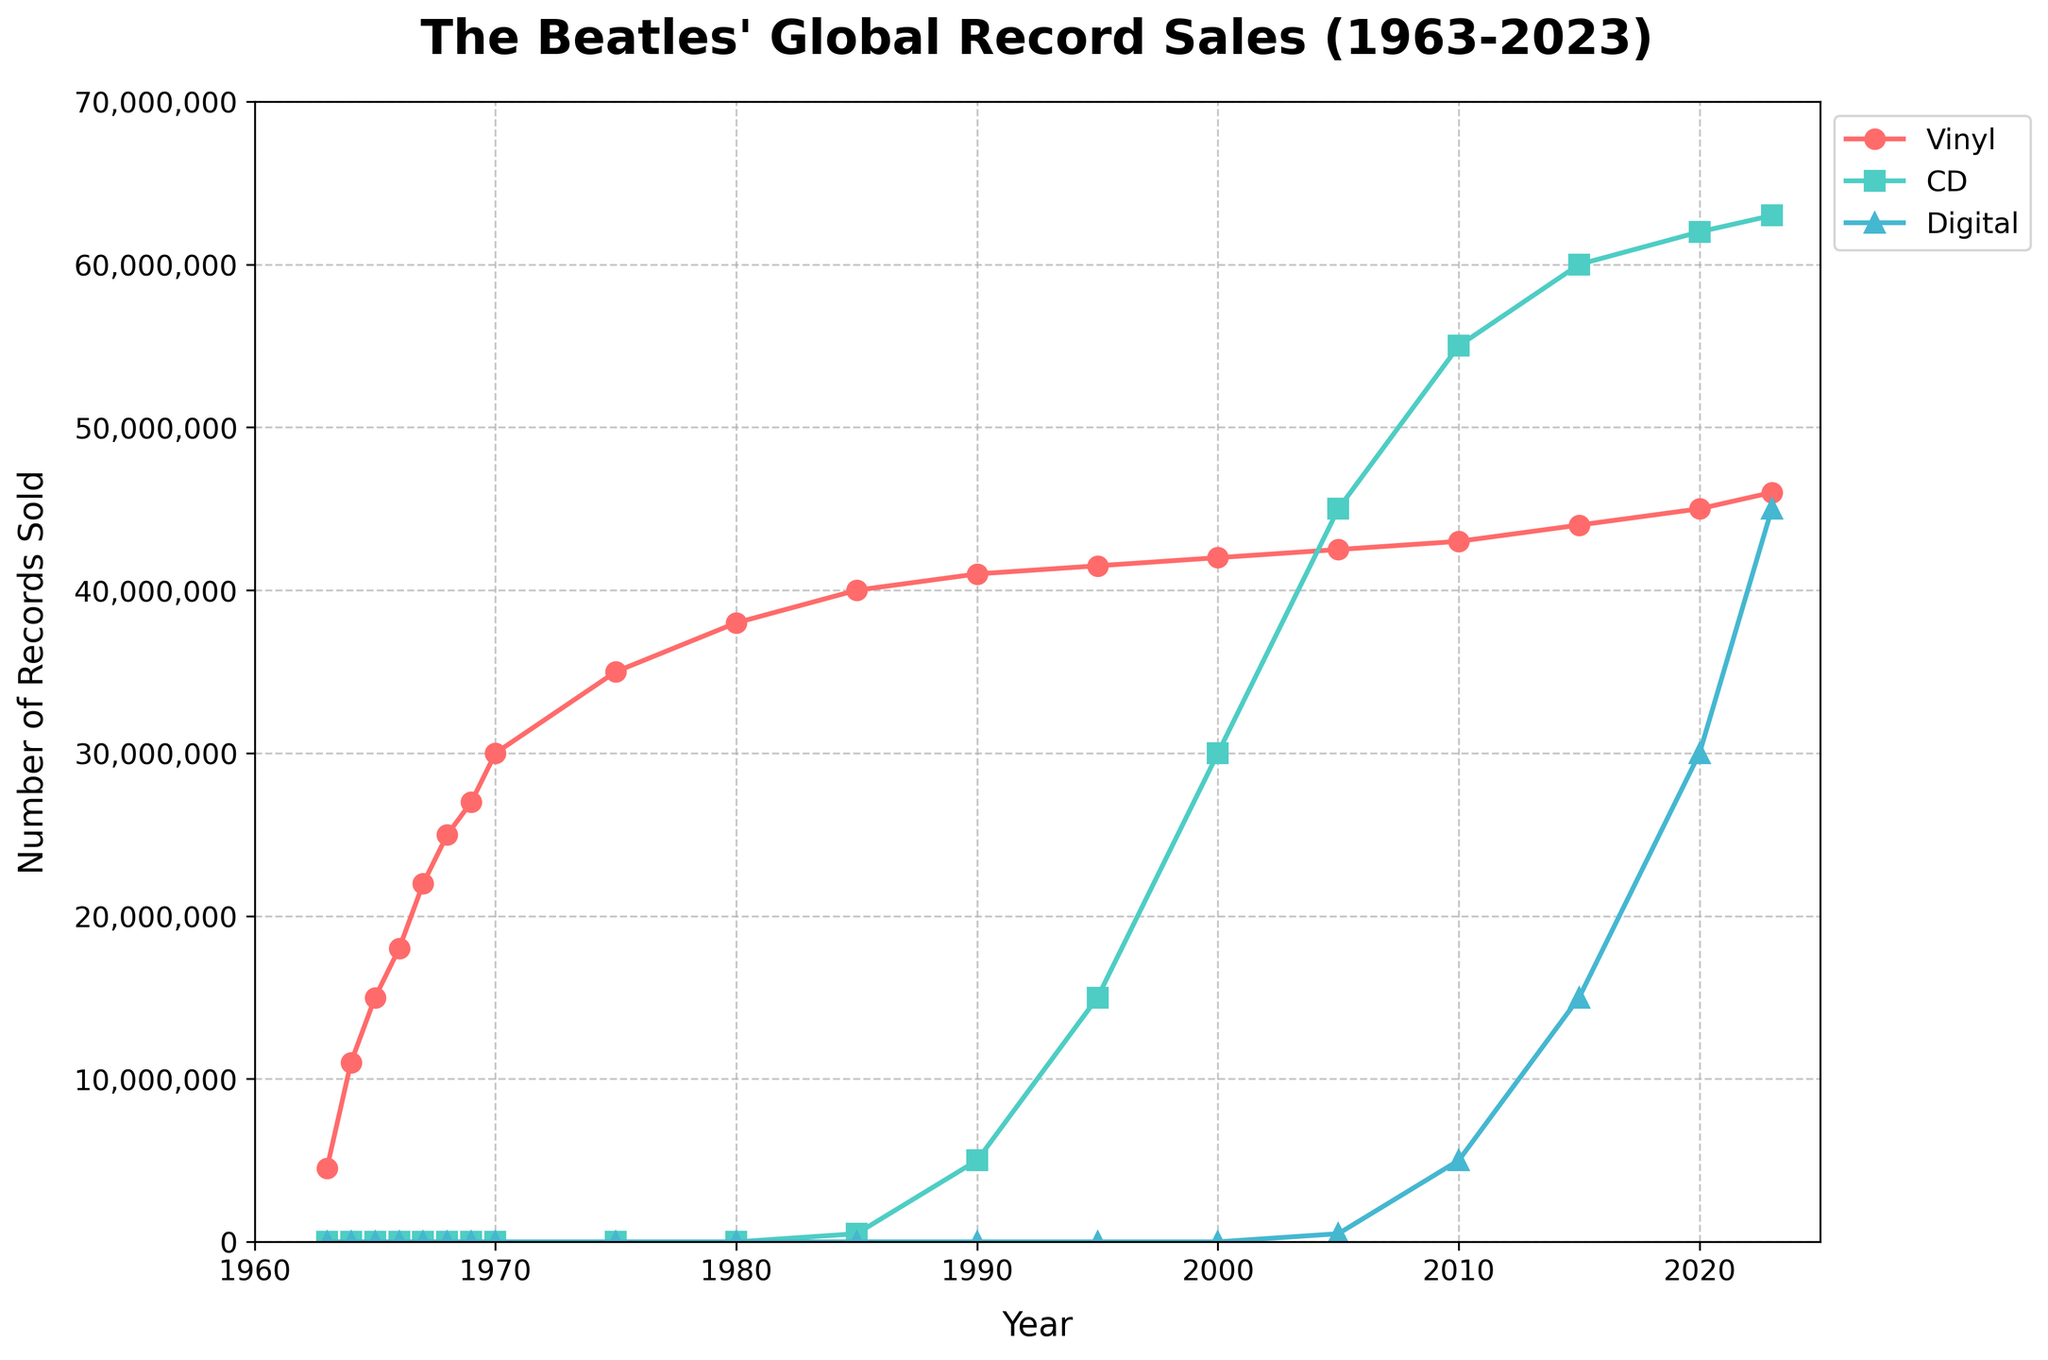How has the number of vinyl records sold changed from 1963 to 2023? From the figure, in 1963, the number of vinyl records sold was 4,500,000 and increased steadily each year, reaching 46,000,000 by 2023.
Answer: Increased by 41,500,000 In which year did CD sales overtake vinyl sales? In 2005, the number of CD sales (45,000,000) exceeded the number of vinyl sales (42,500,000).
Answer: 2005 By how much did digital sales increase from 2005 to 2023? In 2005, digital sales were 500,000 and increased to 45,000,000 by 2023. The difference is 45,000,000 - 500,000 = 44,500,000.
Answer: 44,500,000 Which format had the largest growth in sales from its inception to 2023? Digital sales grew from 0 in 1963 to 45,000,000 in 2023, while vinyl and CD had incremental growth. The largest numeric growth occurred in CD format (63,000,000 - 0) = 63,000,000.
Answer: CD Compare the sales of vinyl, CD, and digital formats in 2023. Which had the most and least sales? In 2023, vinyl sales were 46,000,000, CD sales were 63,000,000, and digital sales were 45,000,000. CDs had the most, and digital had the least sales.
Answer: CDs most, digital least What was the trend of vinyl sales from 1963 to 1985? The trend shows a consistent increase in vinyl sales from 4,500,000 in 1963 to 40,000,000 in 1985.
Answer: Steady increase In which year did digital sales first appear, and what was the sales figure? Digital sales first appeared in 2005 with 500,000 records sold.
Answer: 2005, 500,000 What is the average number of CD sales from 1985 to 2000? The CD sales numbers from 1985 to 2000 are 500,000, 5,000,000, 15,000,000, and 30,000,000. The average is (500,000 + 5,000,000 + 15,000,000 + 30,000,000)/4 = 50,500,000 / 4 = 12,625,000.
Answer: 12,625,000 How do the vinyl sales in 1985 compare to CD sales in 1990? In 1985, vinyl sales were 40,000,000, while in 1990, CD sales were 5,000,000. Vinyl sales in 1985 were higher.
Answer: Vinyl sales were higher What was the year-on-year growth of digital sales between 2015 and 2020? Digital sales in 2015 were 15,000,000 and in 2020 were 30,000,000. So the growth is 30,000,000 - 15,000,000 = 15,000,000 across 5 years, averaging (15,000,000 / 5) = 3,000,000 per year.
Answer: 3,000,000 per year 